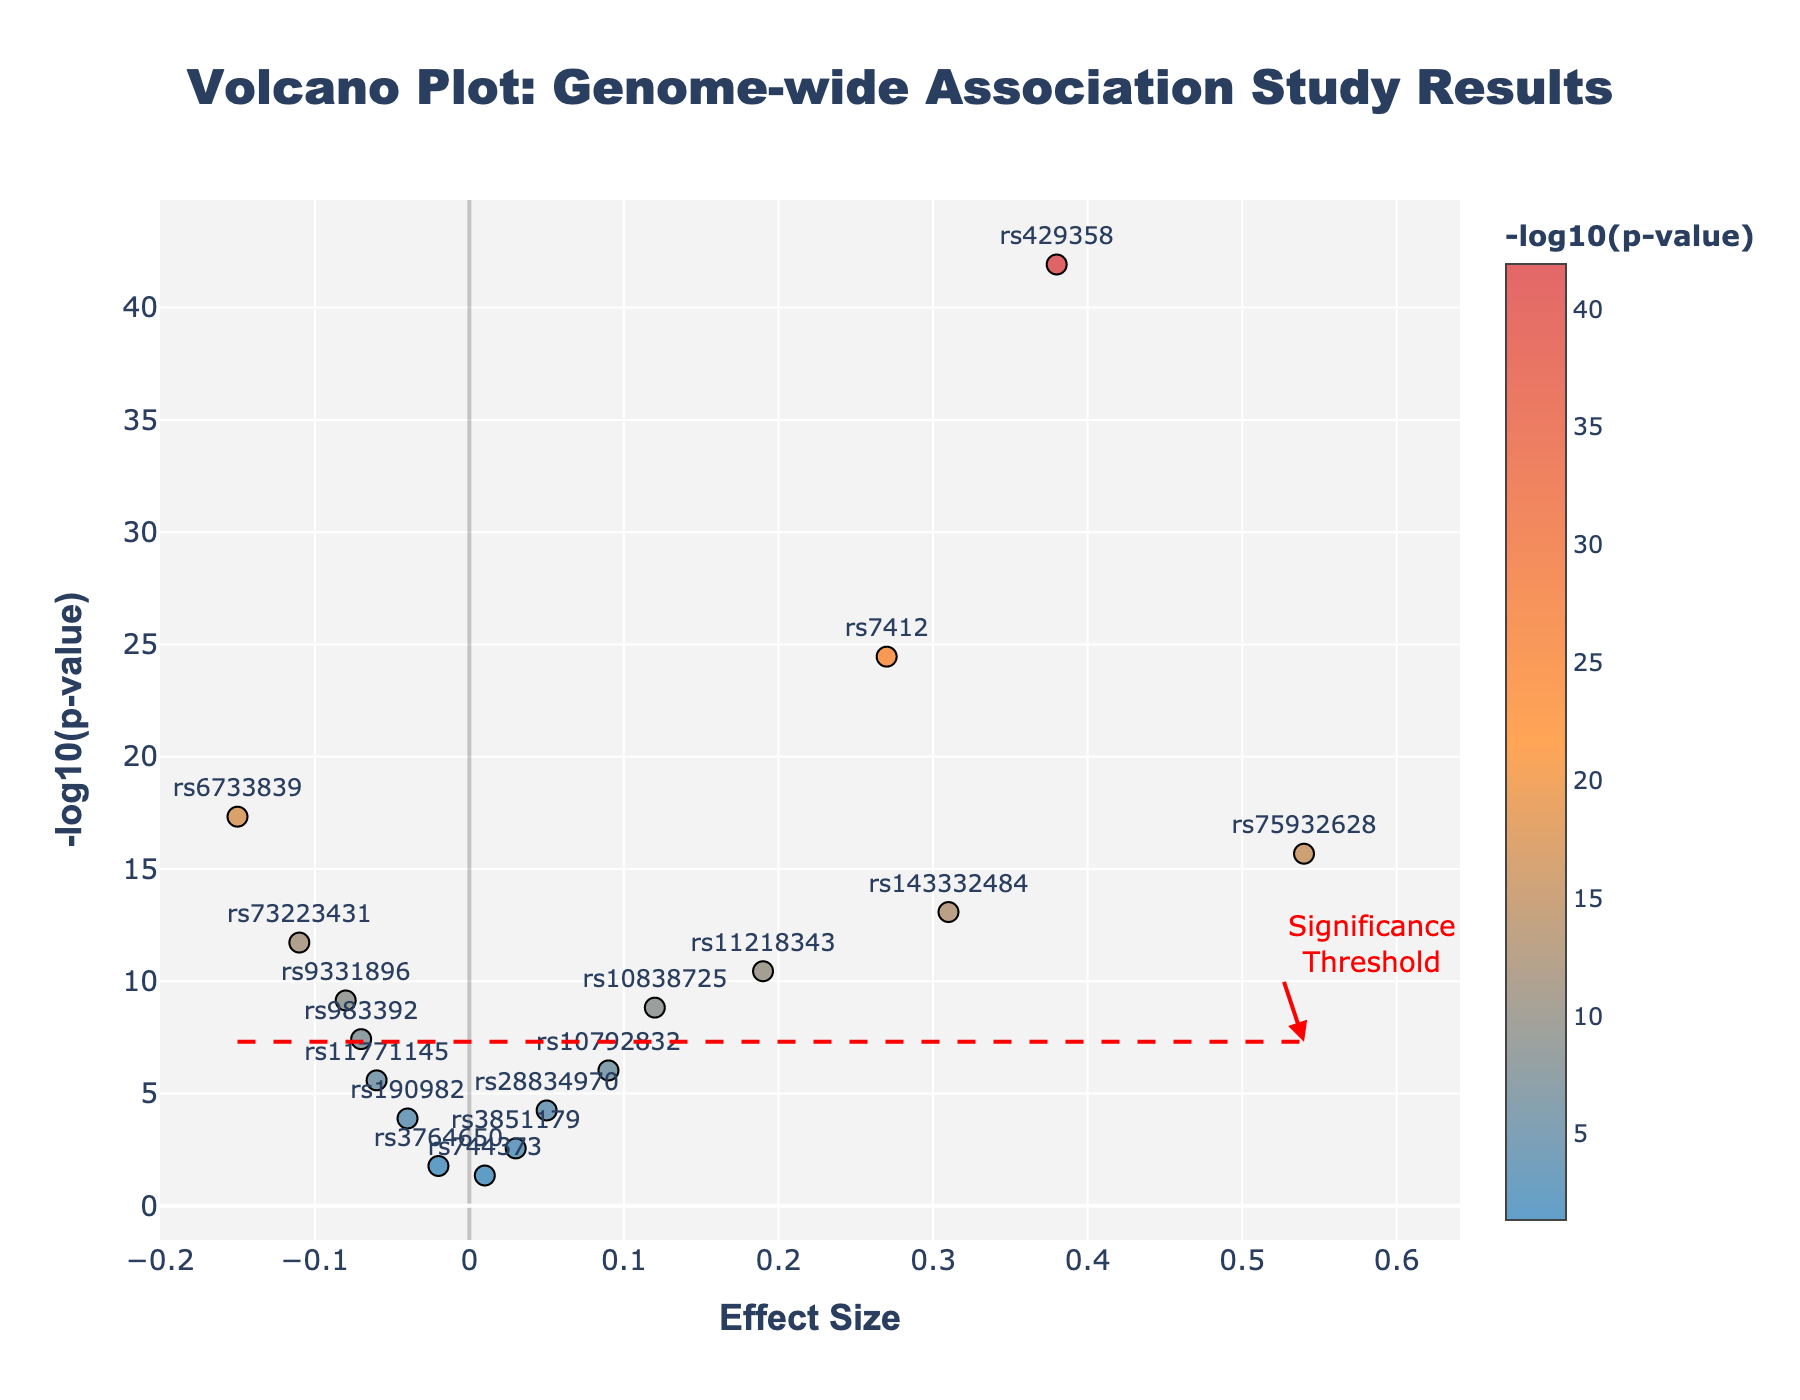What's the title of the plot? The title of the plot is displayed at the top center in bold. It reads "Volcano Plot: Genome-wide Association Study Results".
Answer: Volcano Plot: Genome-wide Association Study Results How many SNPs are plotted in the figure? By counting each marker (circle) on the plot, you can determine the total number of SNPs represented. There are 16 markers displayed in the figure.
Answer: 16 What are the axes labels? The labels for the axes are written next to each respective axis. The x-axis label is "Effect Size" and the y-axis label is "-log10(p-value)."
Answer: Effect Size, -log10(p-value) Which SNP has the highest -log10(p-value)? By looking at the vertical position of each marker, the SNP with the highest -log10(p-value) will be at the top. "rs429358" is at the top, making it the one with the highest -log10(p-value).
Answer: rs429358 Which SNP has the largest positive effect size? The SNP with the largest positive effect size will be the one farthest to the right on the x-axis. "rs75932628" is the furthest to the right, indicating it has the largest positive effect size.
Answer: rs75932628 How many SNPs exceed the significance threshold? The significance threshold is indicated by a horizontal red dashed line. Count the SNPs above this line. 10 SNPs are above the significance threshold.
Answer: 10 Which SNPs have negative effect sizes and are significant? Refer to the markers on the left side of the x-axis (negative effect size) that are above the significance threshold (red dashed line). The SNPs are "rs6733839" and "rs73223431".
Answer: rs6733839, rs73223431 What is the difference in -log10(p-value) between rs429358 and rs10792832? Find the -log10(p-value) for both SNPs and subtract the value of rs10792832 from rs429358. The -log10(p-value) for rs429358 is 42, and for rs10792832 is 6. The difference is 42 - 6 = 36.
Answer: 36 Which SNP has the smallest effect size that is still significant? Locate the SNP with the smallest absolute value of effect size that is above the red dashed line. "rs73223431" has an effect size of -0.11, which is the smallest among the significant SNPs.
Answer: rs73223431 